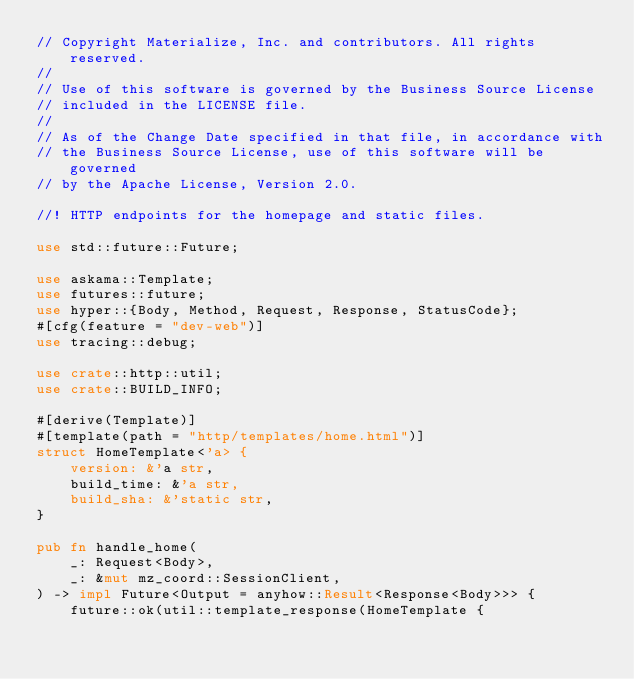Convert code to text. <code><loc_0><loc_0><loc_500><loc_500><_Rust_>// Copyright Materialize, Inc. and contributors. All rights reserved.
//
// Use of this software is governed by the Business Source License
// included in the LICENSE file.
//
// As of the Change Date specified in that file, in accordance with
// the Business Source License, use of this software will be governed
// by the Apache License, Version 2.0.

//! HTTP endpoints for the homepage and static files.

use std::future::Future;

use askama::Template;
use futures::future;
use hyper::{Body, Method, Request, Response, StatusCode};
#[cfg(feature = "dev-web")]
use tracing::debug;

use crate::http::util;
use crate::BUILD_INFO;

#[derive(Template)]
#[template(path = "http/templates/home.html")]
struct HomeTemplate<'a> {
    version: &'a str,
    build_time: &'a str,
    build_sha: &'static str,
}

pub fn handle_home(
    _: Request<Body>,
    _: &mut mz_coord::SessionClient,
) -> impl Future<Output = anyhow::Result<Response<Body>>> {
    future::ok(util::template_response(HomeTemplate {</code> 